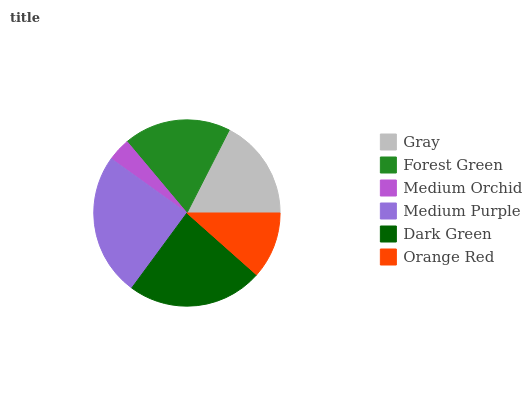Is Medium Orchid the minimum?
Answer yes or no. Yes. Is Medium Purple the maximum?
Answer yes or no. Yes. Is Forest Green the minimum?
Answer yes or no. No. Is Forest Green the maximum?
Answer yes or no. No. Is Forest Green greater than Gray?
Answer yes or no. Yes. Is Gray less than Forest Green?
Answer yes or no. Yes. Is Gray greater than Forest Green?
Answer yes or no. No. Is Forest Green less than Gray?
Answer yes or no. No. Is Forest Green the high median?
Answer yes or no. Yes. Is Gray the low median?
Answer yes or no. Yes. Is Medium Purple the high median?
Answer yes or no. No. Is Medium Purple the low median?
Answer yes or no. No. 